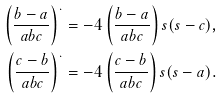<formula> <loc_0><loc_0><loc_500><loc_500>\left ( \frac { b - a } { a b c } \right ) ^ { . } & = - 4 \left ( \frac { b - a } { a b c } \right ) s ( s - c ) , \\ \left ( \frac { c - b } { a b c } \right ) ^ { . } & = - 4 \left ( \frac { c - b } { a b c } \right ) s ( s - a ) .</formula> 